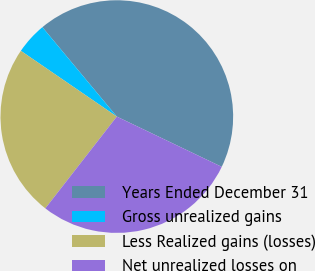Convert chart. <chart><loc_0><loc_0><loc_500><loc_500><pie_chart><fcel>Years Ended December 31<fcel>Gross unrealized gains<fcel>Less Realized gains (losses)<fcel>Net unrealized losses on<nl><fcel>43.16%<fcel>4.39%<fcel>24.03%<fcel>28.42%<nl></chart> 